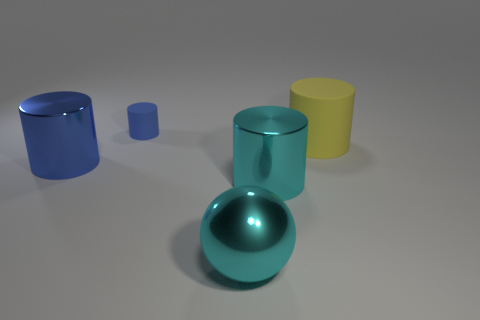Subtract all yellow matte cylinders. How many cylinders are left? 3 Subtract 3 cylinders. How many cylinders are left? 1 Subtract all yellow cylinders. How many cylinders are left? 3 Add 2 tiny brown metal objects. How many objects exist? 7 Subtract all brown cubes. How many purple balls are left? 0 Subtract all purple matte balls. Subtract all big cylinders. How many objects are left? 2 Add 4 tiny cylinders. How many tiny cylinders are left? 5 Add 5 blue matte cubes. How many blue matte cubes exist? 5 Subtract 0 brown blocks. How many objects are left? 5 Subtract all cylinders. How many objects are left? 1 